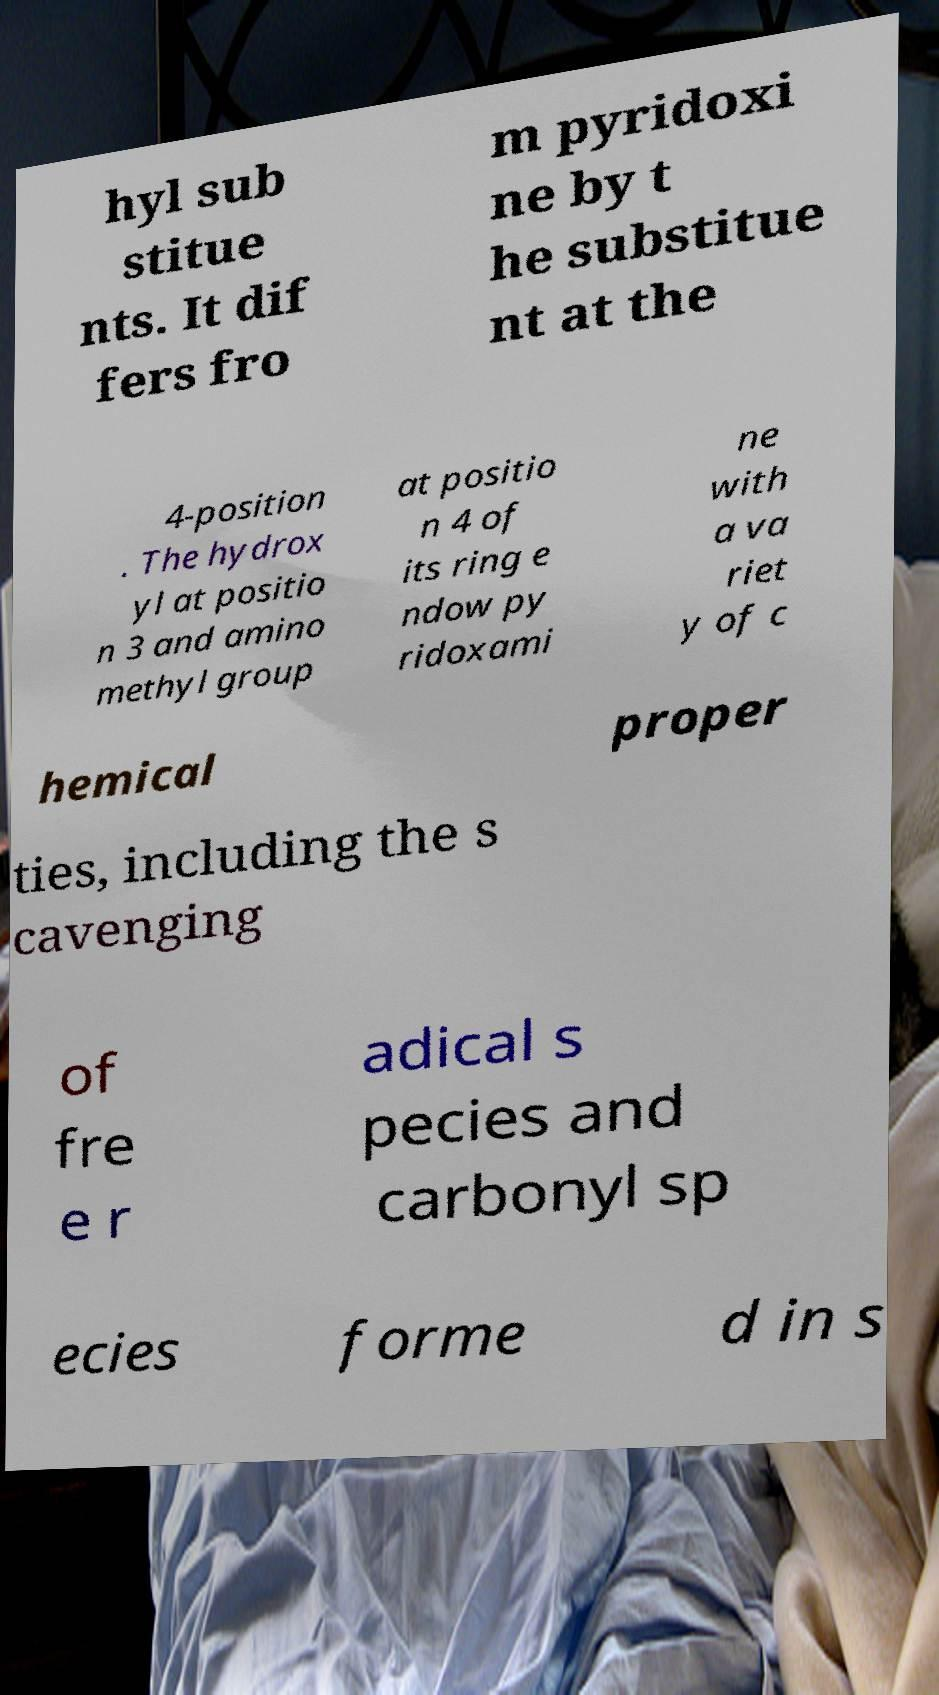Could you extract and type out the text from this image? hyl sub stitue nts. It dif fers fro m pyridoxi ne by t he substitue nt at the 4-position . The hydrox yl at positio n 3 and amino methyl group at positio n 4 of its ring e ndow py ridoxami ne with a va riet y of c hemical proper ties, including the s cavenging of fre e r adical s pecies and carbonyl sp ecies forme d in s 